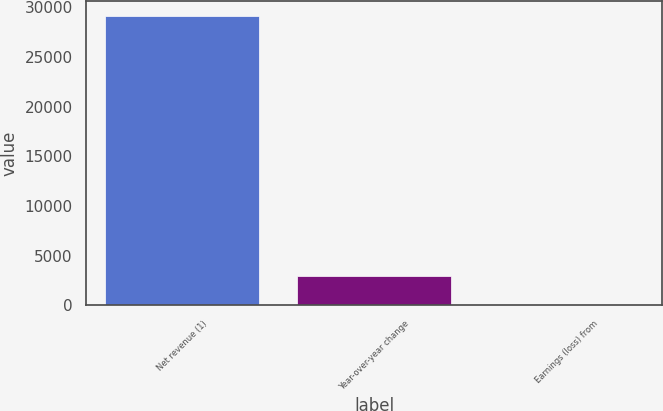<chart> <loc_0><loc_0><loc_500><loc_500><bar_chart><fcel>Net revenue (1)<fcel>Year-over-year change<fcel>Earnings (loss) from<nl><fcel>29135<fcel>2917.46<fcel>4.4<nl></chart> 